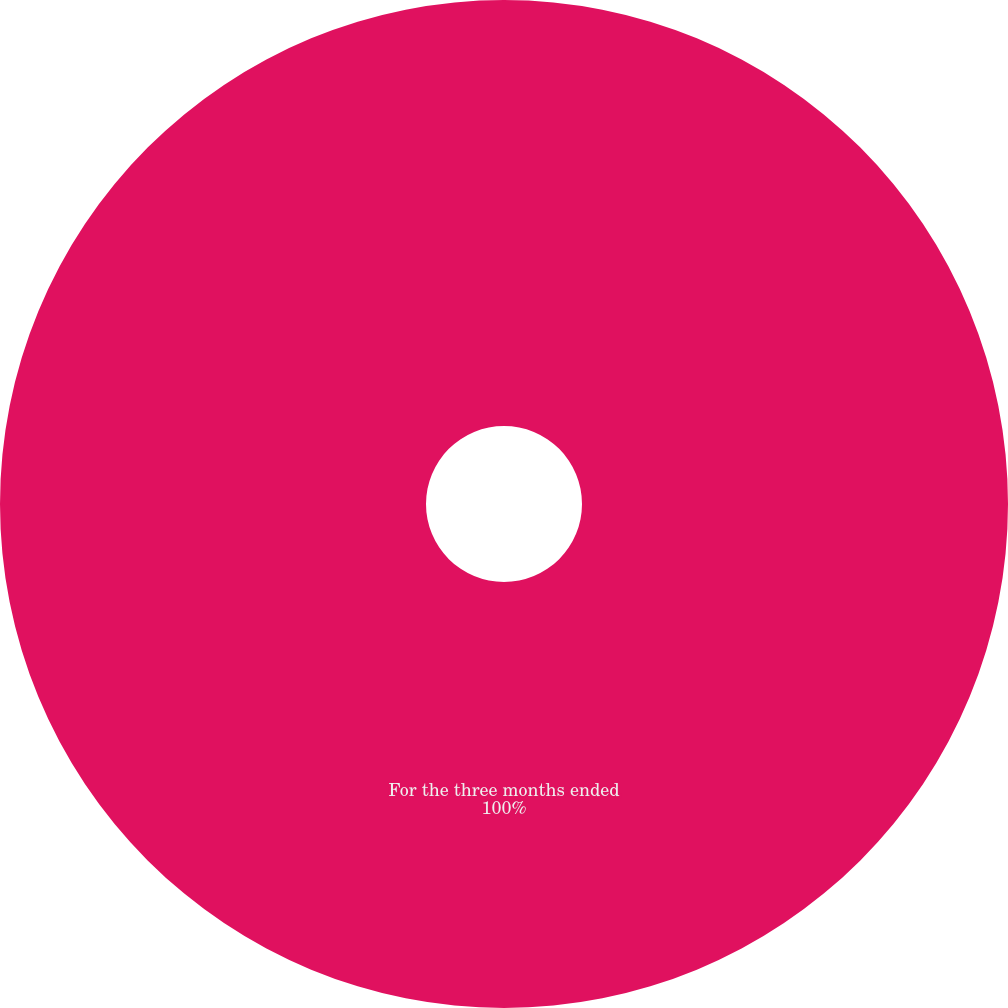Convert chart. <chart><loc_0><loc_0><loc_500><loc_500><pie_chart><fcel>For the three months ended<nl><fcel>100.0%<nl></chart> 